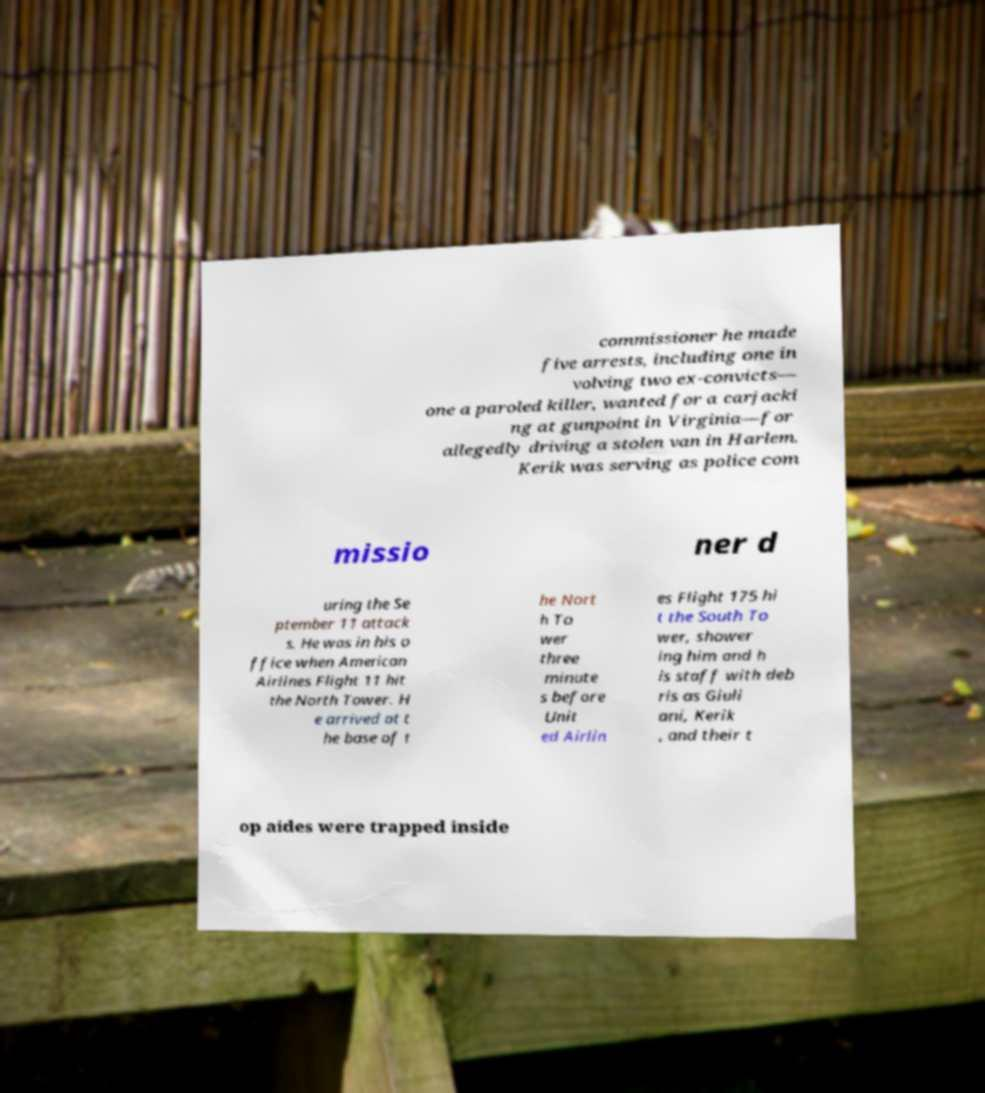Please read and relay the text visible in this image. What does it say? commissioner he made five arrests, including one in volving two ex-convicts— one a paroled killer, wanted for a carjacki ng at gunpoint in Virginia—for allegedly driving a stolen van in Harlem. Kerik was serving as police com missio ner d uring the Se ptember 11 attack s. He was in his o ffice when American Airlines Flight 11 hit the North Tower. H e arrived at t he base of t he Nort h To wer three minute s before Unit ed Airlin es Flight 175 hi t the South To wer, shower ing him and h is staff with deb ris as Giuli ani, Kerik , and their t op aides were trapped inside 